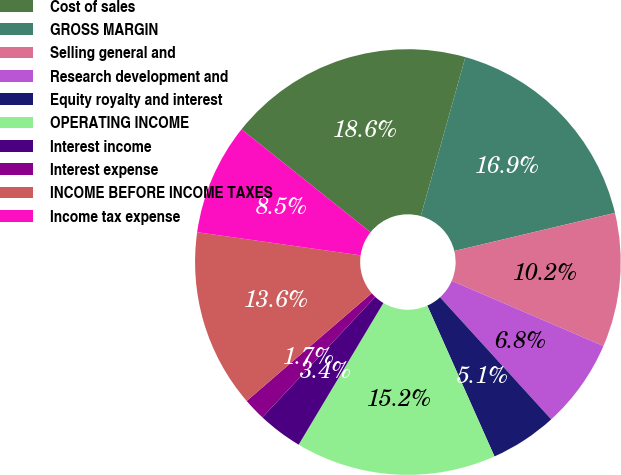<chart> <loc_0><loc_0><loc_500><loc_500><pie_chart><fcel>Cost of sales<fcel>GROSS MARGIN<fcel>Selling general and<fcel>Research development and<fcel>Equity royalty and interest<fcel>OPERATING INCOME<fcel>Interest income<fcel>Interest expense<fcel>INCOME BEFORE INCOME TAXES<fcel>Income tax expense<nl><fcel>18.64%<fcel>16.94%<fcel>10.17%<fcel>6.78%<fcel>5.09%<fcel>15.25%<fcel>3.4%<fcel>1.7%<fcel>13.56%<fcel>8.48%<nl></chart> 